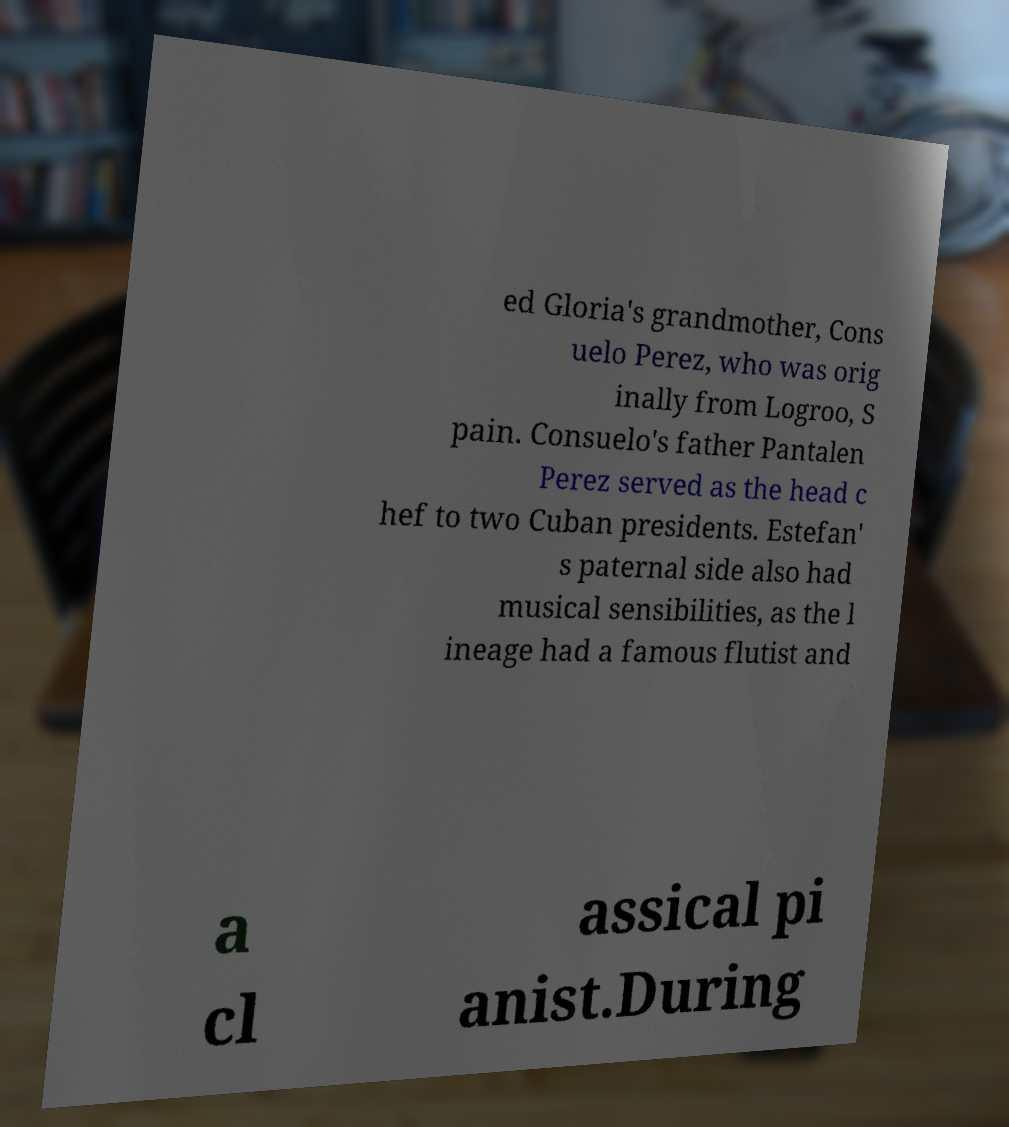Can you read and provide the text displayed in the image?This photo seems to have some interesting text. Can you extract and type it out for me? ed Gloria's grandmother, Cons uelo Perez, who was orig inally from Logroo, S pain. Consuelo's father Pantalen Perez served as the head c hef to two Cuban presidents. Estefan' s paternal side also had musical sensibilities, as the l ineage had a famous flutist and a cl assical pi anist.During 